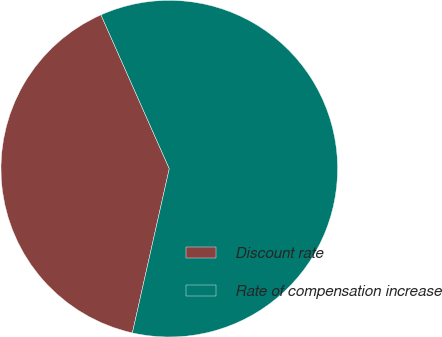Convert chart to OTSL. <chart><loc_0><loc_0><loc_500><loc_500><pie_chart><fcel>Discount rate<fcel>Rate of compensation increase<nl><fcel>39.83%<fcel>60.17%<nl></chart> 